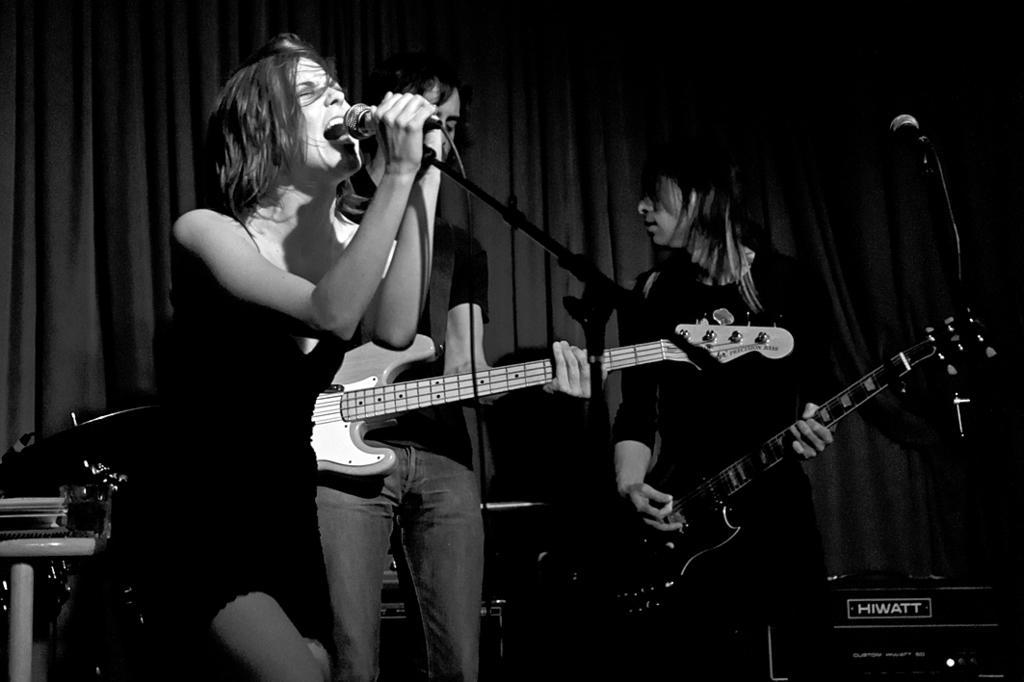How would you summarize this image in a sentence or two? In the picture we can find two woman is singing a song in micro phone and other woman is holding a guitar, just back side to them there is one more person holding a guitar. In the background we can find a curtain and a black shade. 